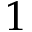<formula> <loc_0><loc_0><loc_500><loc_500>1</formula> 